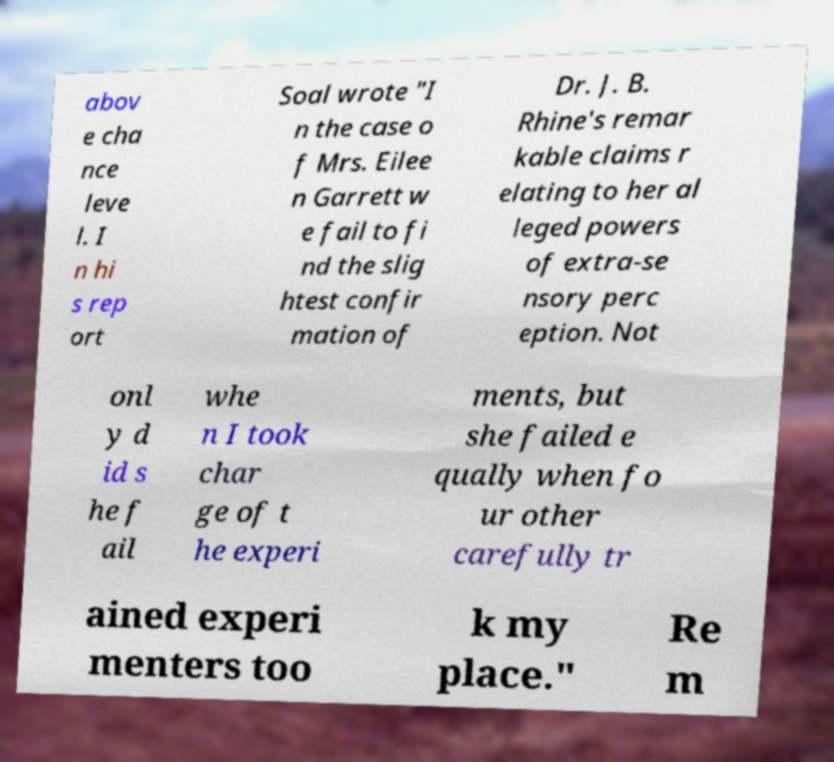Could you assist in decoding the text presented in this image and type it out clearly? abov e cha nce leve l. I n hi s rep ort Soal wrote "I n the case o f Mrs. Eilee n Garrett w e fail to fi nd the slig htest confir mation of Dr. J. B. Rhine's remar kable claims r elating to her al leged powers of extra-se nsory perc eption. Not onl y d id s he f ail whe n I took char ge of t he experi ments, but she failed e qually when fo ur other carefully tr ained experi menters too k my place." Re m 